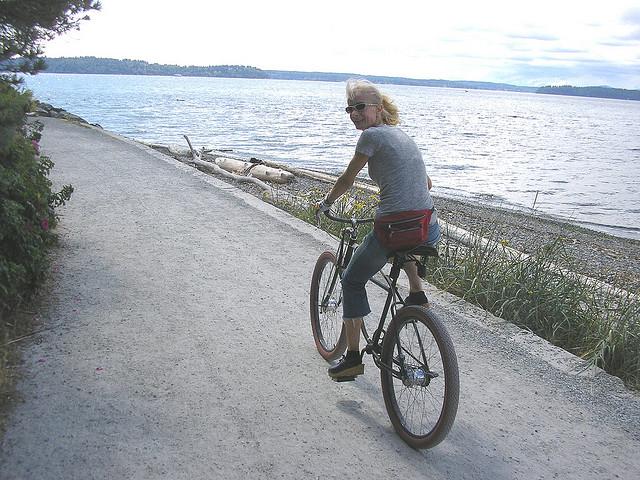What is to the right of the road?
Short answer required. Water. Is the girl biking alone?
Keep it brief. Yes. Is the woman looking in the direction she is traveling?
Quick response, please. No. 